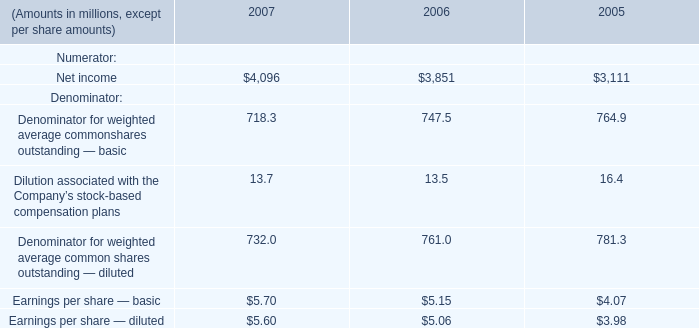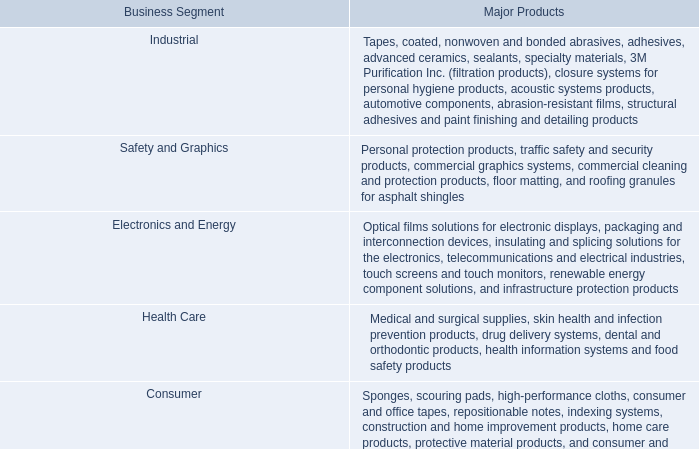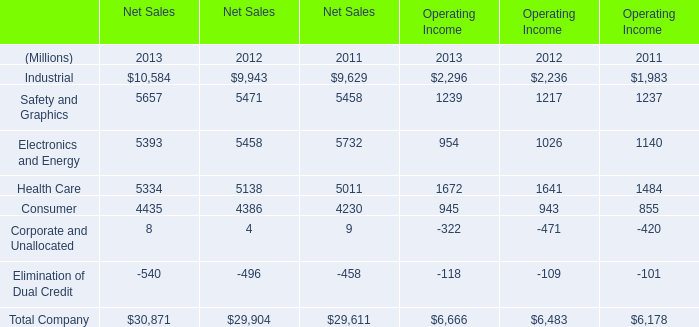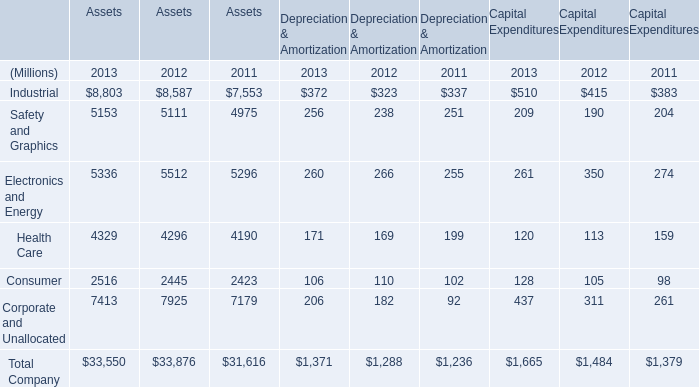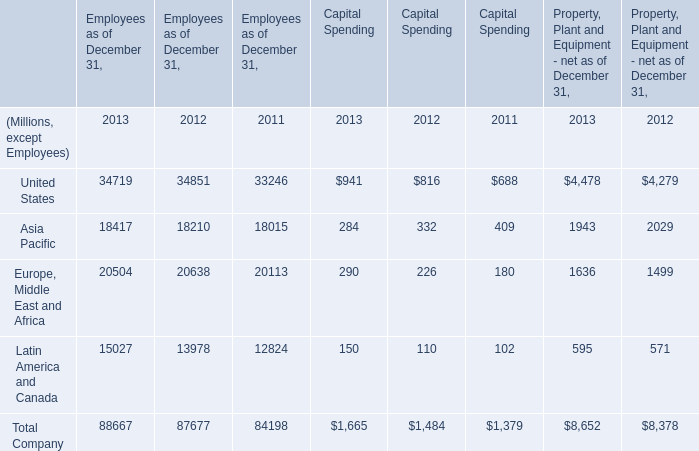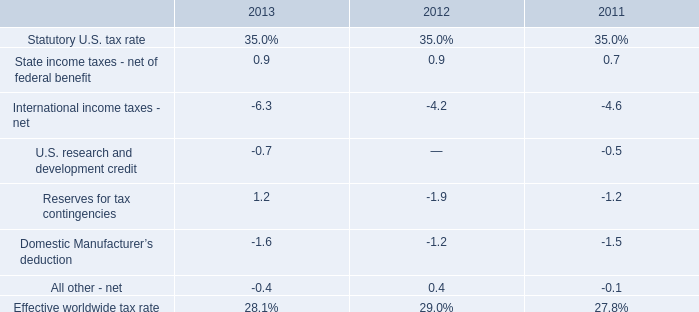What's the sum of Asia Pacific of Employees as of December 31, 2013, Industrial of Operating Income 2012, and Health Care of Net Sales 2013 ? 
Computations: ((18417.0 + 2236.0) + 5334.0)
Answer: 25987.0. 